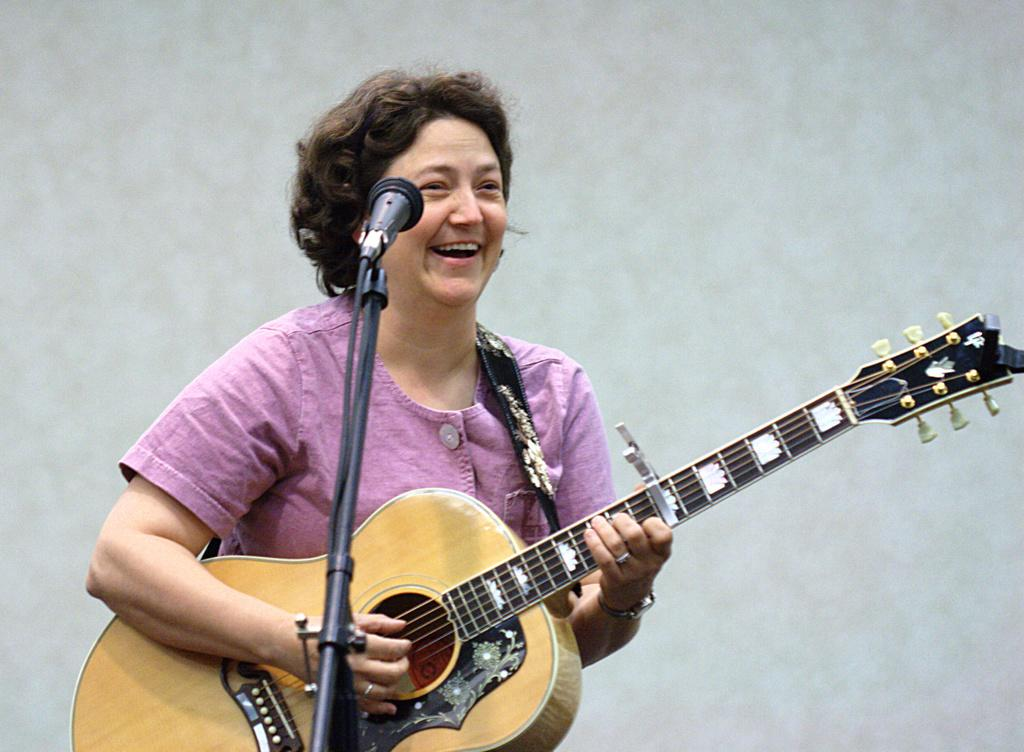Who is the main subject in the image? There is a woman in the image. What is the woman wearing? The woman is wearing a pink shirt. What is the woman holding in the image? The woman is holding a guitar. What is the woman doing with the guitar? The woman is playing the guitar. What is in front of the woman? There is a microphone in front of the woman. What is the woman's facial expression? The woman is smiling. Can you tell me how many clocks are hanging on the wall behind the woman in the image? There is no information about clocks or a wall in the image, so it is not possible to answer this question. What type of leather material is used for the guitar strap in the image? There is no information about the guitar strap or any leather material in the image, so it is not possible to answer this question. 